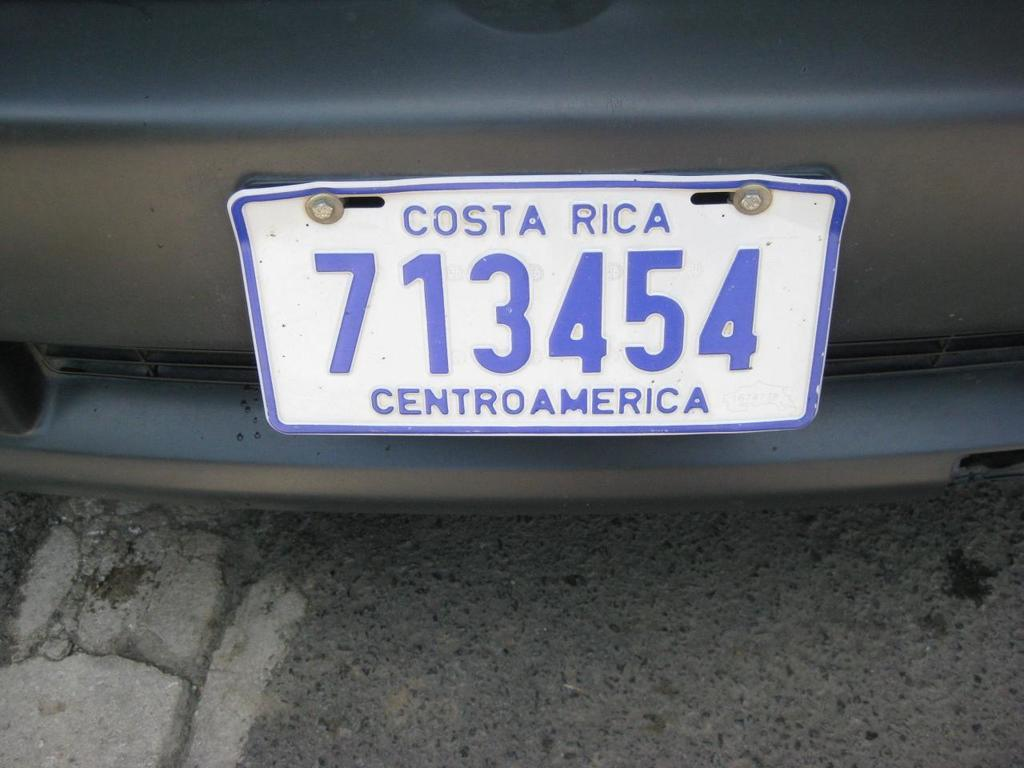<image>
Offer a succinct explanation of the picture presented. A blue and white liscense plate from Costa Rica in CentroAmerica. 